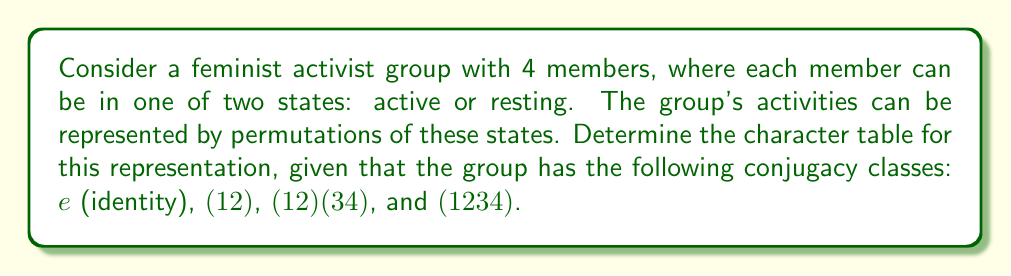Give your solution to this math problem. To determine the character table, we follow these steps:

1. Identify the conjugacy classes and their sizes:
   $C_1 = \{e\}$, size 1
   $C_2 = \{(12), (13), (14), (23), (24), (34)\}$, size 6
   $C_3 = \{(12)(34), (13)(24), (14)(23)\}$, size 3
   $C_4 = \{(1234), (1432), (1243), (1342), (1324), (1423)\}$, size 6

2. The number of irreducible representations equals the number of conjugacy classes, so we have 4 irreducible representations.

3. The dimensions of these representations must satisfy:
   $1^2 + 1^2 + 1^2 + 3^2 = 16$ (order of the group)

4. We know the trivial representation $\chi_1$ has all characters 1.

5. For $\chi_2$ and $\chi_3$, we can deduce:
   $\chi_2((12)) = -1$ (as it's a sign representation)
   $\chi_3((12)) = 1$ (as it's the other 1-dimensional rep)

6. For the 3-dimensional representation $\chi_4$:
   $\chi_4(e) = 3$
   $\chi_4((12)) = 1$ (as the trace of the permutation matrix)
   $\chi_4((12)(34)) = -1$
   $\chi_4((1234)) = -1$

7. We can now complete the character table:

   $$
   \begin{array}{c|cccc}
   & e & (12) & (12)(34) & (1234) \\
   \hline
   \chi_1 & 1 & 1 & 1 & 1 \\
   \chi_2 & 1 & -1 & 1 & -1 \\
   \chi_3 & 1 & 1 & 1 & -1 \\
   \chi_4 & 3 & 1 & -1 & -1
   \end{array}
   $$

This character table represents how the feminist activist group's states transform under different permutations, reflecting the structure of their collective actions.
Answer: $$
\begin{array}{c|cccc}
& e & (12) & (12)(34) & (1234) \\
\hline
\chi_1 & 1 & 1 & 1 & 1 \\
\chi_2 & 1 & -1 & 1 & -1 \\
\chi_3 & 1 & 1 & 1 & -1 \\
\chi_4 & 3 & 1 & -1 & -1
\end{array}
$$ 